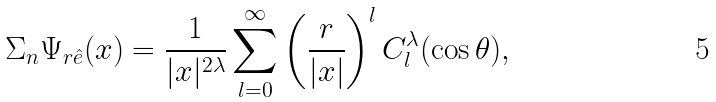Convert formula to latex. <formula><loc_0><loc_0><loc_500><loc_500>\Sigma _ { n } \Psi _ { r \hat { e } } ( x ) = \frac { 1 } { | x | ^ { 2 \lambda } } \sum _ { l = 0 } ^ { \infty } \left ( \frac { r } { | x | } \right ) ^ { l } C _ { l } ^ { \lambda } ( \cos \theta ) ,</formula> 